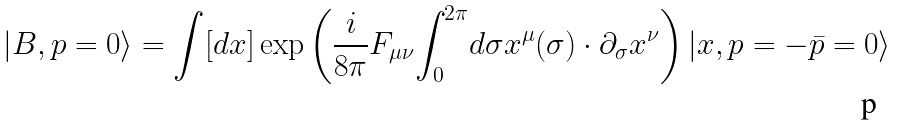Convert formula to latex. <formula><loc_0><loc_0><loc_500><loc_500>| B , p = 0 \rangle = \int [ d x ] \exp \left ( { \frac { i } { 8 \pi } } F _ { \mu \nu } { \int _ { 0 } } ^ { 2 \pi } d \sigma x ^ { \mu } ( \sigma ) \cdot \partial _ { \sigma } x ^ { \nu } \right ) | x , p = - \bar { p } = 0 \rangle</formula> 